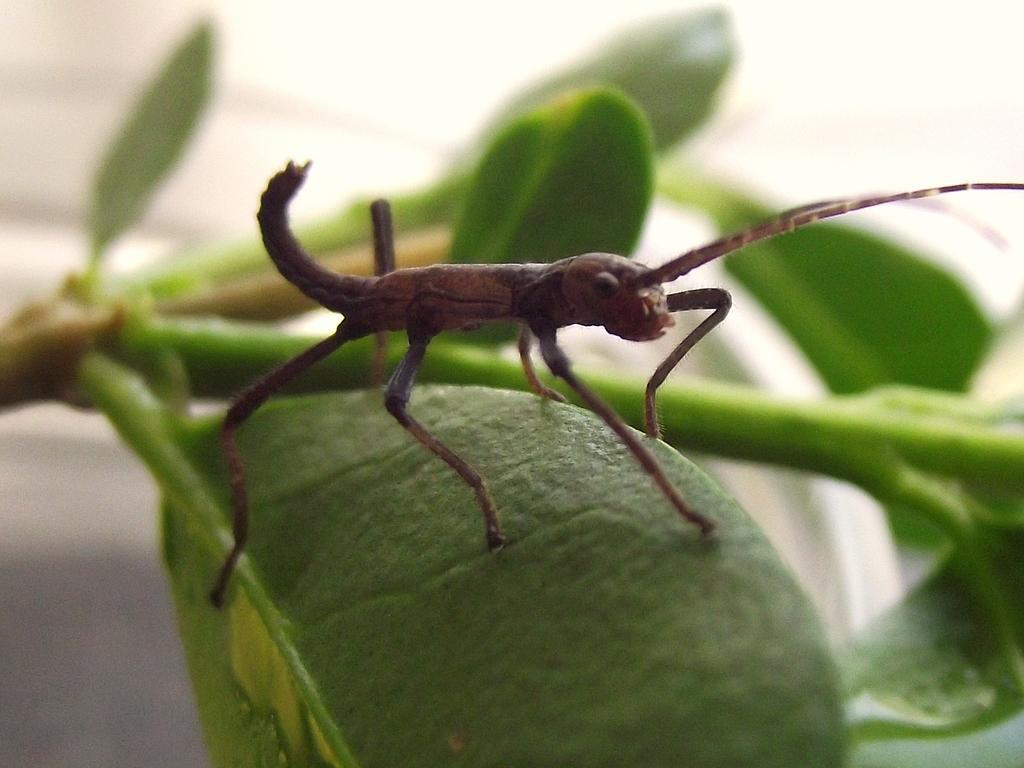Please provide a concise description of this image. In this picture there is an insect on the leaf. In the back I can see the plant branches. In the background I can see the blur image. 